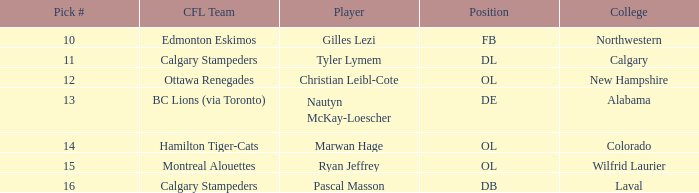Which player from the 2004 CFL draft attended Wilfrid Laurier? Ryan Jeffrey. 